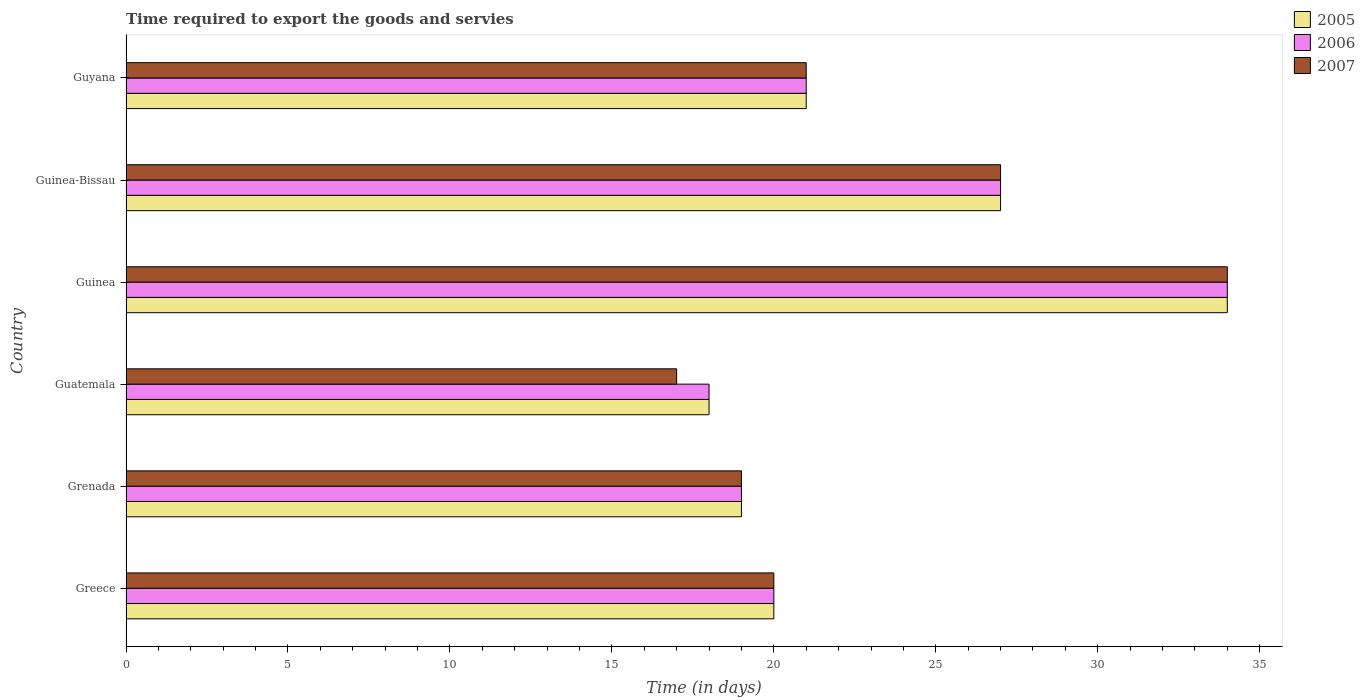How many different coloured bars are there?
Offer a very short reply. 3. Are the number of bars per tick equal to the number of legend labels?
Provide a succinct answer. Yes. Are the number of bars on each tick of the Y-axis equal?
Offer a very short reply. Yes. How many bars are there on the 6th tick from the top?
Give a very brief answer. 3. How many bars are there on the 3rd tick from the bottom?
Make the answer very short. 3. What is the label of the 3rd group of bars from the top?
Your answer should be very brief. Guinea. What is the number of days required to export the goods and services in 2005 in Guyana?
Your answer should be compact. 21. Across all countries, what is the maximum number of days required to export the goods and services in 2007?
Your response must be concise. 34. In which country was the number of days required to export the goods and services in 2006 maximum?
Your response must be concise. Guinea. In which country was the number of days required to export the goods and services in 2005 minimum?
Offer a very short reply. Guatemala. What is the total number of days required to export the goods and services in 2006 in the graph?
Provide a succinct answer. 139. What is the difference between the number of days required to export the goods and services in 2006 in Greece and that in Guinea-Bissau?
Your answer should be very brief. -7. What is the average number of days required to export the goods and services in 2006 per country?
Ensure brevity in your answer.  23.17. In how many countries, is the number of days required to export the goods and services in 2007 greater than 11 days?
Your answer should be compact. 6. What is the ratio of the number of days required to export the goods and services in 2006 in Grenada to that in Guinea?
Keep it short and to the point. 0.56. Is the difference between the number of days required to export the goods and services in 2005 in Guatemala and Guinea-Bissau greater than the difference between the number of days required to export the goods and services in 2007 in Guatemala and Guinea-Bissau?
Keep it short and to the point. Yes. What is the difference between the highest and the second highest number of days required to export the goods and services in 2005?
Provide a succinct answer. 7. What does the 2nd bar from the top in Guinea-Bissau represents?
Ensure brevity in your answer.  2006. Is it the case that in every country, the sum of the number of days required to export the goods and services in 2005 and number of days required to export the goods and services in 2007 is greater than the number of days required to export the goods and services in 2006?
Keep it short and to the point. Yes. How many countries are there in the graph?
Keep it short and to the point. 6. Does the graph contain grids?
Provide a succinct answer. No. Where does the legend appear in the graph?
Your answer should be compact. Top right. How many legend labels are there?
Your answer should be very brief. 3. How are the legend labels stacked?
Your answer should be very brief. Vertical. What is the title of the graph?
Offer a terse response. Time required to export the goods and servies. What is the label or title of the X-axis?
Ensure brevity in your answer.  Time (in days). What is the Time (in days) in 2007 in Greece?
Ensure brevity in your answer.  20. What is the Time (in days) of 2006 in Grenada?
Make the answer very short. 19. What is the Time (in days) of 2007 in Grenada?
Give a very brief answer. 19. What is the Time (in days) of 2005 in Guatemala?
Your answer should be very brief. 18. What is the Time (in days) in 2006 in Guatemala?
Keep it short and to the point. 18. What is the Time (in days) of 2007 in Guatemala?
Ensure brevity in your answer.  17. What is the Time (in days) of 2006 in Guinea?
Keep it short and to the point. 34. What is the Time (in days) of 2007 in Guinea?
Offer a very short reply. 34. What is the Time (in days) in 2006 in Guinea-Bissau?
Ensure brevity in your answer.  27. Across all countries, what is the maximum Time (in days) in 2005?
Provide a succinct answer. 34. Across all countries, what is the maximum Time (in days) of 2006?
Give a very brief answer. 34. Across all countries, what is the minimum Time (in days) of 2005?
Give a very brief answer. 18. Across all countries, what is the minimum Time (in days) in 2007?
Provide a succinct answer. 17. What is the total Time (in days) of 2005 in the graph?
Provide a succinct answer. 139. What is the total Time (in days) in 2006 in the graph?
Ensure brevity in your answer.  139. What is the total Time (in days) in 2007 in the graph?
Your answer should be very brief. 138. What is the difference between the Time (in days) in 2005 in Greece and that in Grenada?
Give a very brief answer. 1. What is the difference between the Time (in days) of 2006 in Greece and that in Grenada?
Provide a succinct answer. 1. What is the difference between the Time (in days) of 2007 in Greece and that in Grenada?
Keep it short and to the point. 1. What is the difference between the Time (in days) of 2005 in Greece and that in Guatemala?
Keep it short and to the point. 2. What is the difference between the Time (in days) of 2007 in Greece and that in Guatemala?
Offer a terse response. 3. What is the difference between the Time (in days) of 2005 in Greece and that in Guinea?
Your answer should be very brief. -14. What is the difference between the Time (in days) in 2006 in Greece and that in Guinea?
Ensure brevity in your answer.  -14. What is the difference between the Time (in days) in 2007 in Greece and that in Guinea?
Offer a terse response. -14. What is the difference between the Time (in days) of 2005 in Greece and that in Guinea-Bissau?
Your response must be concise. -7. What is the difference between the Time (in days) in 2006 in Greece and that in Guinea-Bissau?
Offer a very short reply. -7. What is the difference between the Time (in days) of 2006 in Greece and that in Guyana?
Your answer should be very brief. -1. What is the difference between the Time (in days) in 2007 in Greece and that in Guyana?
Make the answer very short. -1. What is the difference between the Time (in days) in 2007 in Grenada and that in Guatemala?
Keep it short and to the point. 2. What is the difference between the Time (in days) in 2006 in Grenada and that in Guinea?
Your answer should be compact. -15. What is the difference between the Time (in days) of 2007 in Grenada and that in Guinea?
Make the answer very short. -15. What is the difference between the Time (in days) in 2005 in Grenada and that in Guinea-Bissau?
Make the answer very short. -8. What is the difference between the Time (in days) in 2007 in Grenada and that in Guyana?
Make the answer very short. -2. What is the difference between the Time (in days) in 2005 in Guatemala and that in Guinea?
Offer a terse response. -16. What is the difference between the Time (in days) of 2006 in Guatemala and that in Guinea?
Offer a terse response. -16. What is the difference between the Time (in days) of 2005 in Guatemala and that in Guinea-Bissau?
Offer a very short reply. -9. What is the difference between the Time (in days) in 2006 in Guatemala and that in Guinea-Bissau?
Make the answer very short. -9. What is the difference between the Time (in days) of 2006 in Guinea and that in Guinea-Bissau?
Provide a short and direct response. 7. What is the difference between the Time (in days) in 2007 in Guinea and that in Guyana?
Offer a very short reply. 13. What is the difference between the Time (in days) of 2005 in Guinea-Bissau and that in Guyana?
Ensure brevity in your answer.  6. What is the difference between the Time (in days) of 2006 in Guinea-Bissau and that in Guyana?
Give a very brief answer. 6. What is the difference between the Time (in days) in 2005 in Greece and the Time (in days) in 2006 in Grenada?
Offer a very short reply. 1. What is the difference between the Time (in days) in 2005 in Greece and the Time (in days) in 2007 in Grenada?
Make the answer very short. 1. What is the difference between the Time (in days) of 2006 in Greece and the Time (in days) of 2007 in Grenada?
Give a very brief answer. 1. What is the difference between the Time (in days) in 2005 in Greece and the Time (in days) in 2007 in Guatemala?
Provide a short and direct response. 3. What is the difference between the Time (in days) in 2006 in Greece and the Time (in days) in 2007 in Guatemala?
Provide a succinct answer. 3. What is the difference between the Time (in days) of 2005 in Greece and the Time (in days) of 2007 in Guinea?
Provide a succinct answer. -14. What is the difference between the Time (in days) of 2006 in Greece and the Time (in days) of 2007 in Guinea?
Provide a short and direct response. -14. What is the difference between the Time (in days) of 2005 in Greece and the Time (in days) of 2007 in Guinea-Bissau?
Offer a terse response. -7. What is the difference between the Time (in days) of 2006 in Greece and the Time (in days) of 2007 in Guinea-Bissau?
Your response must be concise. -7. What is the difference between the Time (in days) in 2005 in Grenada and the Time (in days) in 2007 in Guatemala?
Provide a succinct answer. 2. What is the difference between the Time (in days) of 2006 in Grenada and the Time (in days) of 2007 in Guatemala?
Provide a short and direct response. 2. What is the difference between the Time (in days) of 2005 in Grenada and the Time (in days) of 2007 in Guinea?
Provide a succinct answer. -15. What is the difference between the Time (in days) in 2006 in Grenada and the Time (in days) in 2007 in Guinea?
Provide a succinct answer. -15. What is the difference between the Time (in days) in 2005 in Grenada and the Time (in days) in 2006 in Guyana?
Your answer should be compact. -2. What is the difference between the Time (in days) of 2005 in Guatemala and the Time (in days) of 2006 in Guinea?
Offer a terse response. -16. What is the difference between the Time (in days) in 2005 in Guatemala and the Time (in days) in 2006 in Guinea-Bissau?
Offer a terse response. -9. What is the difference between the Time (in days) in 2005 in Guatemala and the Time (in days) in 2007 in Guinea-Bissau?
Your answer should be compact. -9. What is the difference between the Time (in days) of 2005 in Guatemala and the Time (in days) of 2007 in Guyana?
Offer a terse response. -3. What is the difference between the Time (in days) of 2006 in Guatemala and the Time (in days) of 2007 in Guyana?
Make the answer very short. -3. What is the difference between the Time (in days) in 2005 in Guinea and the Time (in days) in 2006 in Guyana?
Keep it short and to the point. 13. What is the difference between the Time (in days) in 2005 in Guinea-Bissau and the Time (in days) in 2006 in Guyana?
Ensure brevity in your answer.  6. What is the difference between the Time (in days) of 2005 in Guinea-Bissau and the Time (in days) of 2007 in Guyana?
Your answer should be compact. 6. What is the difference between the Time (in days) of 2006 in Guinea-Bissau and the Time (in days) of 2007 in Guyana?
Your answer should be very brief. 6. What is the average Time (in days) in 2005 per country?
Keep it short and to the point. 23.17. What is the average Time (in days) of 2006 per country?
Ensure brevity in your answer.  23.17. What is the average Time (in days) of 2007 per country?
Offer a terse response. 23. What is the difference between the Time (in days) in 2005 and Time (in days) in 2007 in Greece?
Make the answer very short. 0. What is the difference between the Time (in days) of 2005 and Time (in days) of 2007 in Grenada?
Keep it short and to the point. 0. What is the difference between the Time (in days) of 2005 and Time (in days) of 2006 in Guatemala?
Keep it short and to the point. 0. What is the difference between the Time (in days) of 2006 and Time (in days) of 2007 in Guatemala?
Keep it short and to the point. 1. What is the difference between the Time (in days) in 2005 and Time (in days) in 2006 in Guinea-Bissau?
Provide a short and direct response. 0. What is the difference between the Time (in days) of 2005 and Time (in days) of 2007 in Guinea-Bissau?
Offer a terse response. 0. What is the ratio of the Time (in days) in 2005 in Greece to that in Grenada?
Keep it short and to the point. 1.05. What is the ratio of the Time (in days) of 2006 in Greece to that in Grenada?
Offer a terse response. 1.05. What is the ratio of the Time (in days) of 2007 in Greece to that in Grenada?
Provide a short and direct response. 1.05. What is the ratio of the Time (in days) in 2006 in Greece to that in Guatemala?
Provide a succinct answer. 1.11. What is the ratio of the Time (in days) in 2007 in Greece to that in Guatemala?
Your answer should be compact. 1.18. What is the ratio of the Time (in days) of 2005 in Greece to that in Guinea?
Give a very brief answer. 0.59. What is the ratio of the Time (in days) of 2006 in Greece to that in Guinea?
Offer a terse response. 0.59. What is the ratio of the Time (in days) of 2007 in Greece to that in Guinea?
Provide a short and direct response. 0.59. What is the ratio of the Time (in days) in 2005 in Greece to that in Guinea-Bissau?
Your answer should be very brief. 0.74. What is the ratio of the Time (in days) in 2006 in Greece to that in Guinea-Bissau?
Provide a succinct answer. 0.74. What is the ratio of the Time (in days) of 2007 in Greece to that in Guinea-Bissau?
Make the answer very short. 0.74. What is the ratio of the Time (in days) in 2005 in Greece to that in Guyana?
Provide a succinct answer. 0.95. What is the ratio of the Time (in days) in 2006 in Greece to that in Guyana?
Keep it short and to the point. 0.95. What is the ratio of the Time (in days) of 2007 in Greece to that in Guyana?
Your response must be concise. 0.95. What is the ratio of the Time (in days) of 2005 in Grenada to that in Guatemala?
Provide a succinct answer. 1.06. What is the ratio of the Time (in days) of 2006 in Grenada to that in Guatemala?
Your response must be concise. 1.06. What is the ratio of the Time (in days) in 2007 in Grenada to that in Guatemala?
Keep it short and to the point. 1.12. What is the ratio of the Time (in days) of 2005 in Grenada to that in Guinea?
Your response must be concise. 0.56. What is the ratio of the Time (in days) in 2006 in Grenada to that in Guinea?
Ensure brevity in your answer.  0.56. What is the ratio of the Time (in days) of 2007 in Grenada to that in Guinea?
Provide a succinct answer. 0.56. What is the ratio of the Time (in days) in 2005 in Grenada to that in Guinea-Bissau?
Your answer should be very brief. 0.7. What is the ratio of the Time (in days) of 2006 in Grenada to that in Guinea-Bissau?
Make the answer very short. 0.7. What is the ratio of the Time (in days) of 2007 in Grenada to that in Guinea-Bissau?
Your answer should be compact. 0.7. What is the ratio of the Time (in days) of 2005 in Grenada to that in Guyana?
Ensure brevity in your answer.  0.9. What is the ratio of the Time (in days) of 2006 in Grenada to that in Guyana?
Make the answer very short. 0.9. What is the ratio of the Time (in days) in 2007 in Grenada to that in Guyana?
Offer a terse response. 0.9. What is the ratio of the Time (in days) of 2005 in Guatemala to that in Guinea?
Offer a terse response. 0.53. What is the ratio of the Time (in days) of 2006 in Guatemala to that in Guinea?
Keep it short and to the point. 0.53. What is the ratio of the Time (in days) in 2007 in Guatemala to that in Guinea?
Offer a terse response. 0.5. What is the ratio of the Time (in days) in 2005 in Guatemala to that in Guinea-Bissau?
Make the answer very short. 0.67. What is the ratio of the Time (in days) of 2006 in Guatemala to that in Guinea-Bissau?
Ensure brevity in your answer.  0.67. What is the ratio of the Time (in days) of 2007 in Guatemala to that in Guinea-Bissau?
Your answer should be compact. 0.63. What is the ratio of the Time (in days) in 2005 in Guatemala to that in Guyana?
Give a very brief answer. 0.86. What is the ratio of the Time (in days) of 2006 in Guatemala to that in Guyana?
Provide a succinct answer. 0.86. What is the ratio of the Time (in days) in 2007 in Guatemala to that in Guyana?
Ensure brevity in your answer.  0.81. What is the ratio of the Time (in days) in 2005 in Guinea to that in Guinea-Bissau?
Provide a short and direct response. 1.26. What is the ratio of the Time (in days) of 2006 in Guinea to that in Guinea-Bissau?
Your answer should be very brief. 1.26. What is the ratio of the Time (in days) in 2007 in Guinea to that in Guinea-Bissau?
Offer a very short reply. 1.26. What is the ratio of the Time (in days) in 2005 in Guinea to that in Guyana?
Give a very brief answer. 1.62. What is the ratio of the Time (in days) of 2006 in Guinea to that in Guyana?
Your answer should be compact. 1.62. What is the ratio of the Time (in days) of 2007 in Guinea to that in Guyana?
Make the answer very short. 1.62. What is the ratio of the Time (in days) of 2006 in Guinea-Bissau to that in Guyana?
Offer a terse response. 1.29. What is the ratio of the Time (in days) of 2007 in Guinea-Bissau to that in Guyana?
Provide a succinct answer. 1.29. What is the difference between the highest and the second highest Time (in days) in 2005?
Provide a short and direct response. 7. What is the difference between the highest and the second highest Time (in days) of 2006?
Offer a very short reply. 7. What is the difference between the highest and the second highest Time (in days) in 2007?
Your answer should be compact. 7. What is the difference between the highest and the lowest Time (in days) in 2005?
Your answer should be very brief. 16. What is the difference between the highest and the lowest Time (in days) in 2006?
Your answer should be very brief. 16. 